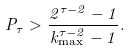<formula> <loc_0><loc_0><loc_500><loc_500>P _ { \tau } > \frac { 2 ^ { \tau - 2 } - 1 } { k _ { \max } ^ { \tau - 2 } - 1 } .</formula> 